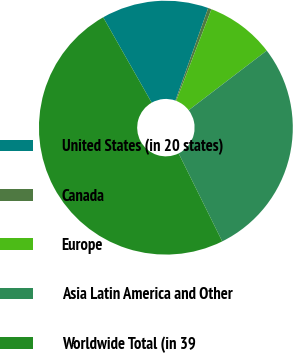Convert chart. <chart><loc_0><loc_0><loc_500><loc_500><pie_chart><fcel>United States (in 20 states)<fcel>Canada<fcel>Europe<fcel>Asia Latin America and Other<fcel>Worldwide Total (in 39<nl><fcel>13.63%<fcel>0.44%<fcel>8.77%<fcel>28.06%<fcel>49.1%<nl></chart> 